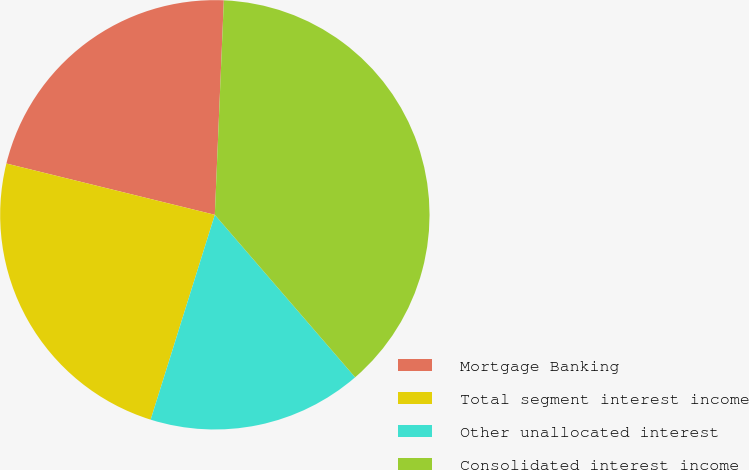Convert chart. <chart><loc_0><loc_0><loc_500><loc_500><pie_chart><fcel>Mortgage Banking<fcel>Total segment interest income<fcel>Other unallocated interest<fcel>Consolidated interest income<nl><fcel>21.83%<fcel>24.01%<fcel>16.17%<fcel>38.0%<nl></chart> 